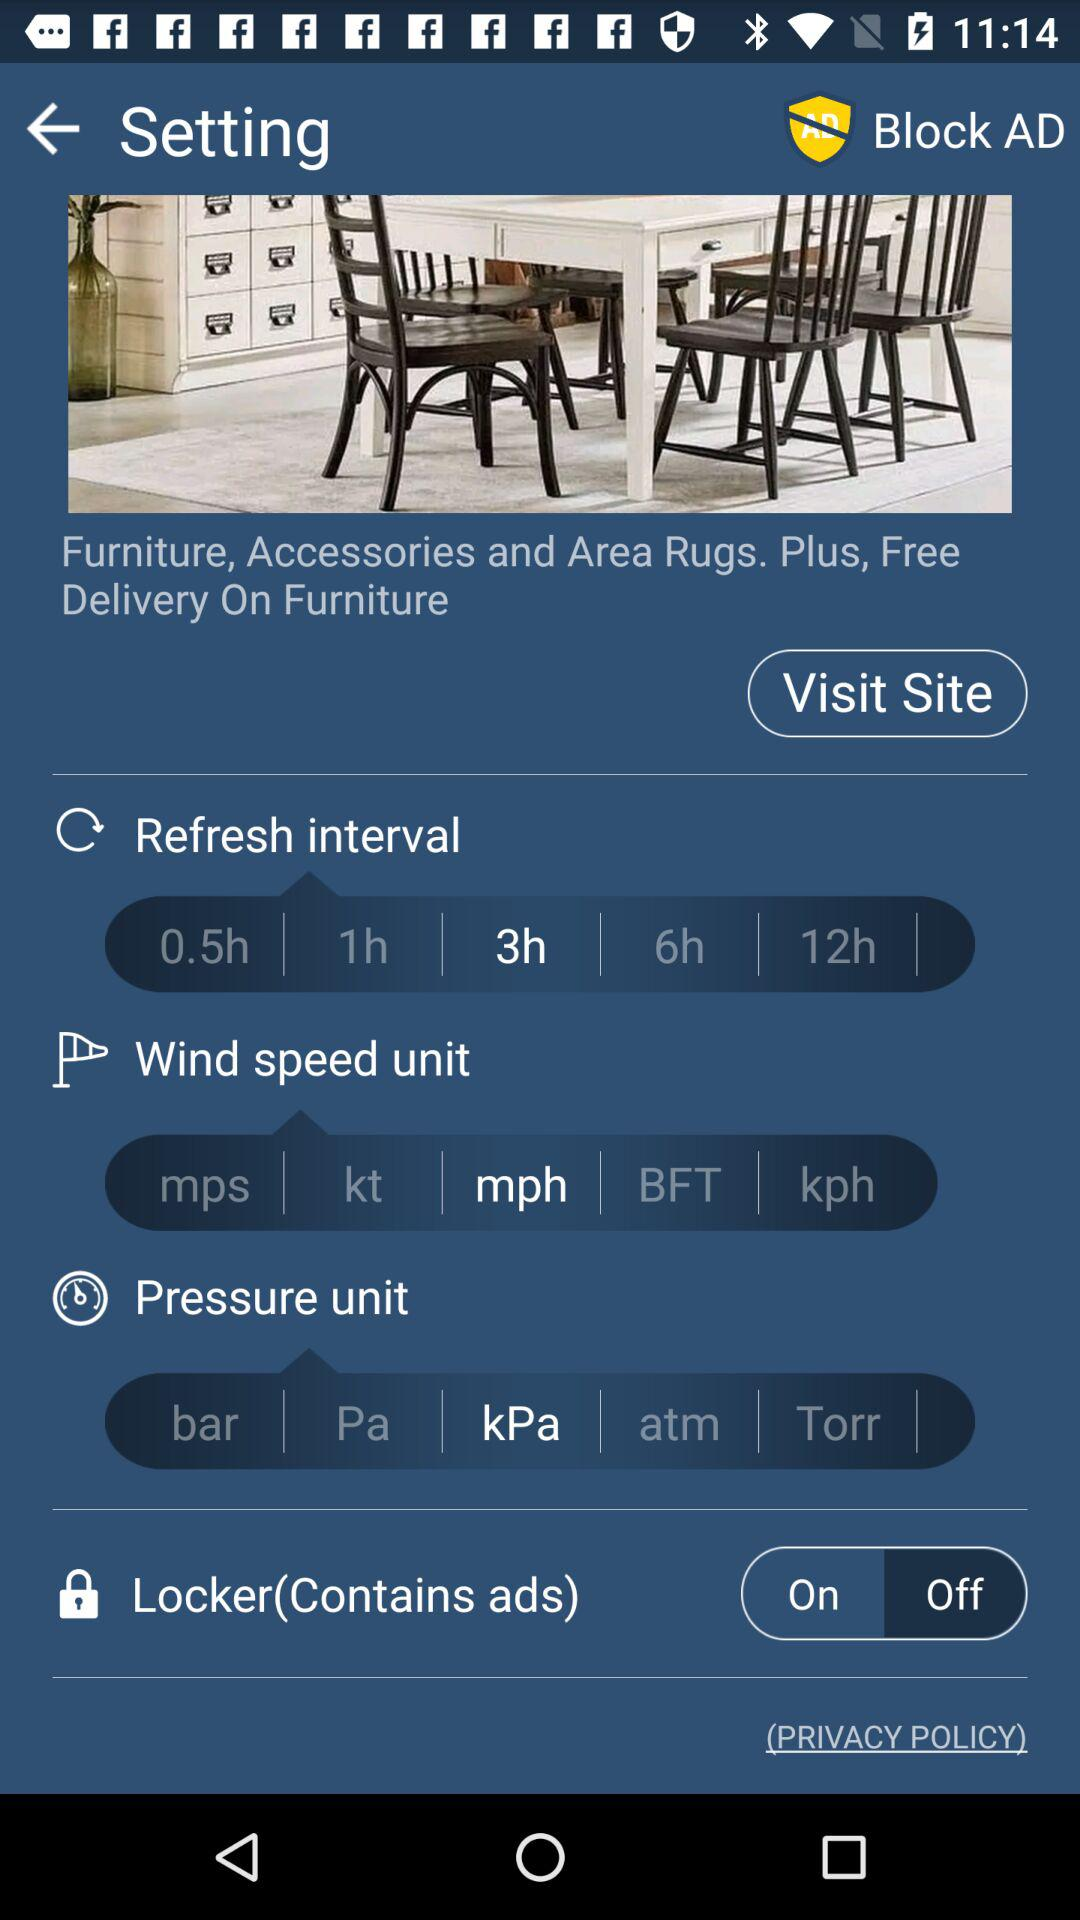What is the status of "Locker"? The status is "on". 